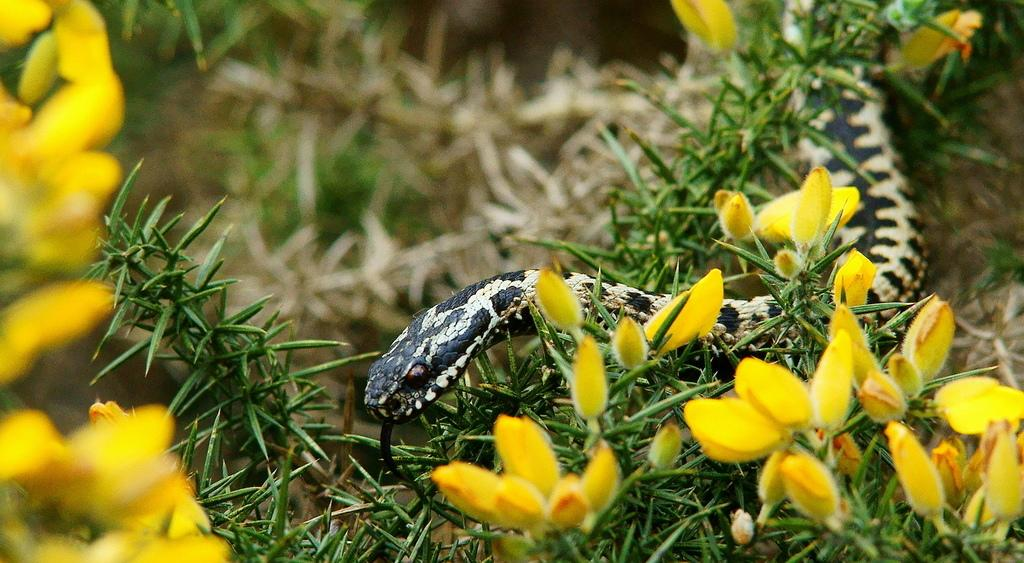What type of plants can be seen in the image? There are flower plants in the image. Where are the flower plants located in the image? The flower plants are at the bottom of the image. What other living creature is present in the image? There is a snake in the image. How is the snake positioned in relation to the flower plants? The snake is in between the flower plants. What type of berry is being used as an example in the image? There is no berry present in the image, nor is there any example being demonstrated. 